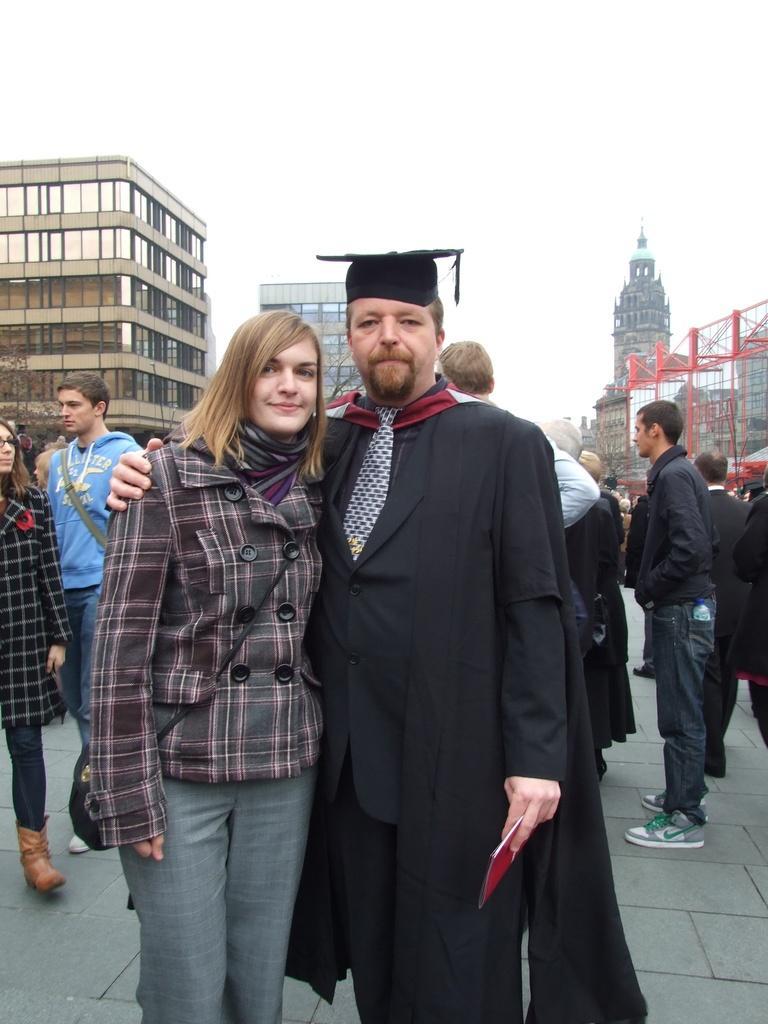Please provide a concise description of this image. In this picture I can see few people are standing and I can see a man is wearing a cap on his head and he is holding a paper in his hand and I can see buildings in the back and I can see sky. 